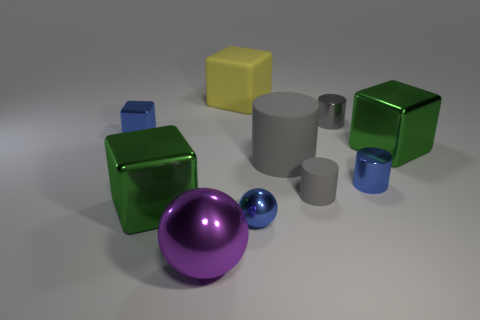Are there the same number of matte things behind the yellow cube and large yellow blocks?
Make the answer very short. No. There is a cylinder that is the same color as the tiny metallic cube; what is its size?
Give a very brief answer. Small. Do the small gray rubber thing and the yellow thing have the same shape?
Offer a very short reply. No. How many things are either small blue metallic objects that are left of the blue metallic sphere or small spheres?
Your answer should be compact. 2. Is the number of blue metal blocks that are to the left of the large gray cylinder the same as the number of small shiny blocks that are on the right side of the tiny cube?
Your answer should be very brief. No. How many other things are the same shape as the big gray thing?
Keep it short and to the point. 3. There is a metal thing that is behind the blue block; does it have the same size as the green block that is to the left of the tiny gray shiny object?
Give a very brief answer. No. How many cubes are either small blue matte objects or yellow things?
Your response must be concise. 1. What number of matte objects are either small cylinders or yellow blocks?
Provide a succinct answer. 2. There is a blue object that is the same shape as the big gray rubber thing; what is its size?
Your response must be concise. Small. 